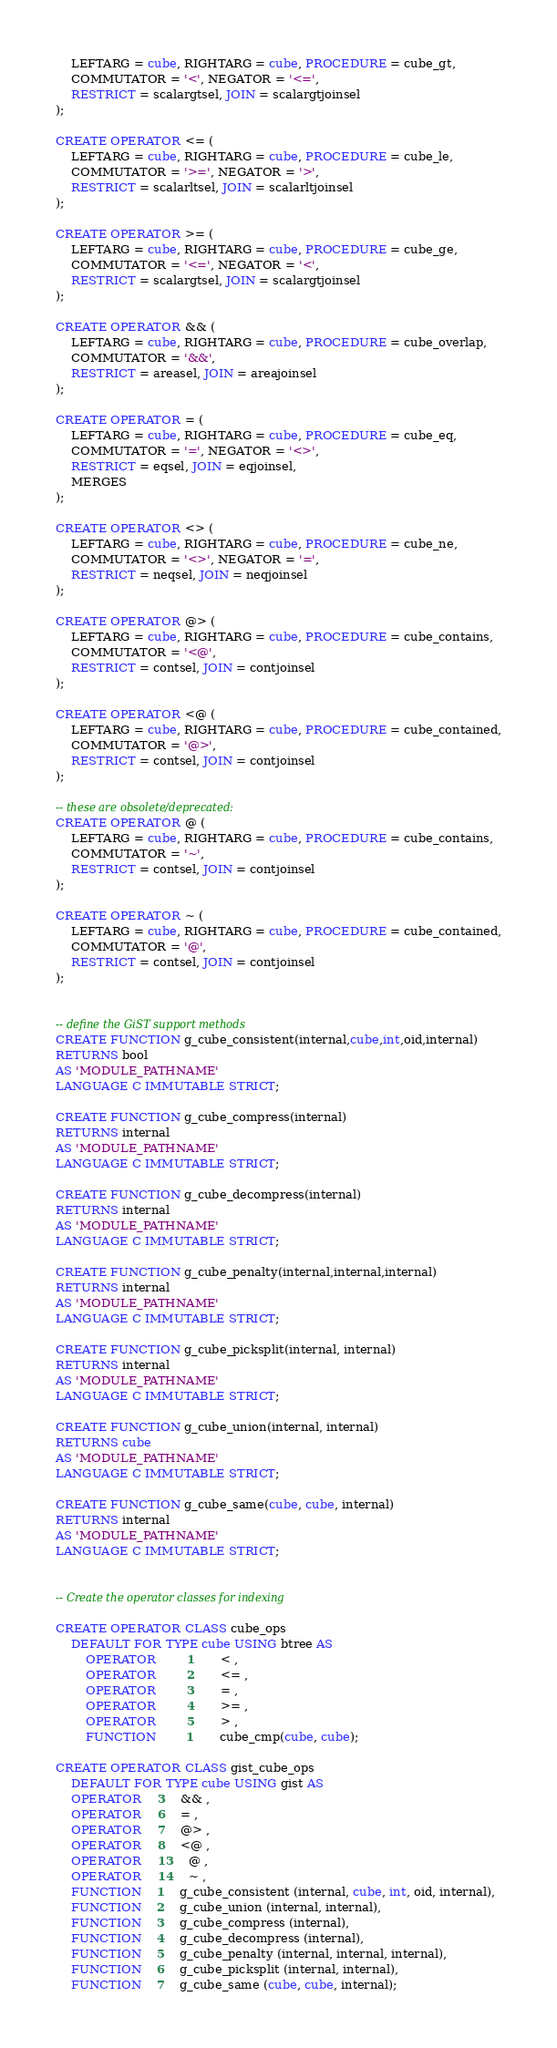<code> <loc_0><loc_0><loc_500><loc_500><_SQL_>	LEFTARG = cube, RIGHTARG = cube, PROCEDURE = cube_gt,
	COMMUTATOR = '<', NEGATOR = '<=',
	RESTRICT = scalargtsel, JOIN = scalargtjoinsel
);

CREATE OPERATOR <= (
	LEFTARG = cube, RIGHTARG = cube, PROCEDURE = cube_le,
	COMMUTATOR = '>=', NEGATOR = '>',
	RESTRICT = scalarltsel, JOIN = scalarltjoinsel
);

CREATE OPERATOR >= (
	LEFTARG = cube, RIGHTARG = cube, PROCEDURE = cube_ge,
	COMMUTATOR = '<=', NEGATOR = '<',
	RESTRICT = scalargtsel, JOIN = scalargtjoinsel
);

CREATE OPERATOR && (
	LEFTARG = cube, RIGHTARG = cube, PROCEDURE = cube_overlap,
	COMMUTATOR = '&&',
	RESTRICT = areasel, JOIN = areajoinsel
);

CREATE OPERATOR = (
	LEFTARG = cube, RIGHTARG = cube, PROCEDURE = cube_eq,
	COMMUTATOR = '=', NEGATOR = '<>',
	RESTRICT = eqsel, JOIN = eqjoinsel,
	MERGES
);

CREATE OPERATOR <> (
	LEFTARG = cube, RIGHTARG = cube, PROCEDURE = cube_ne,
	COMMUTATOR = '<>', NEGATOR = '=',
	RESTRICT = neqsel, JOIN = neqjoinsel
);

CREATE OPERATOR @> (
	LEFTARG = cube, RIGHTARG = cube, PROCEDURE = cube_contains,
	COMMUTATOR = '<@',
	RESTRICT = contsel, JOIN = contjoinsel
);

CREATE OPERATOR <@ (
	LEFTARG = cube, RIGHTARG = cube, PROCEDURE = cube_contained,
	COMMUTATOR = '@>',
	RESTRICT = contsel, JOIN = contjoinsel
);

-- these are obsolete/deprecated:
CREATE OPERATOR @ (
	LEFTARG = cube, RIGHTARG = cube, PROCEDURE = cube_contains,
	COMMUTATOR = '~',
	RESTRICT = contsel, JOIN = contjoinsel
);

CREATE OPERATOR ~ (
	LEFTARG = cube, RIGHTARG = cube, PROCEDURE = cube_contained,
	COMMUTATOR = '@',
	RESTRICT = contsel, JOIN = contjoinsel
);


-- define the GiST support methods
CREATE FUNCTION g_cube_consistent(internal,cube,int,oid,internal)
RETURNS bool
AS 'MODULE_PATHNAME'
LANGUAGE C IMMUTABLE STRICT;

CREATE FUNCTION g_cube_compress(internal)
RETURNS internal
AS 'MODULE_PATHNAME'
LANGUAGE C IMMUTABLE STRICT;

CREATE FUNCTION g_cube_decompress(internal)
RETURNS internal
AS 'MODULE_PATHNAME'
LANGUAGE C IMMUTABLE STRICT;

CREATE FUNCTION g_cube_penalty(internal,internal,internal)
RETURNS internal
AS 'MODULE_PATHNAME'
LANGUAGE C IMMUTABLE STRICT;

CREATE FUNCTION g_cube_picksplit(internal, internal)
RETURNS internal
AS 'MODULE_PATHNAME'
LANGUAGE C IMMUTABLE STRICT;

CREATE FUNCTION g_cube_union(internal, internal)
RETURNS cube
AS 'MODULE_PATHNAME'
LANGUAGE C IMMUTABLE STRICT;

CREATE FUNCTION g_cube_same(cube, cube, internal)
RETURNS internal
AS 'MODULE_PATHNAME'
LANGUAGE C IMMUTABLE STRICT;


-- Create the operator classes for indexing

CREATE OPERATOR CLASS cube_ops
    DEFAULT FOR TYPE cube USING btree AS
        OPERATOR        1       < ,
        OPERATOR        2       <= ,
        OPERATOR        3       = ,
        OPERATOR        4       >= ,
        OPERATOR        5       > ,
        FUNCTION        1       cube_cmp(cube, cube);

CREATE OPERATOR CLASS gist_cube_ops
    DEFAULT FOR TYPE cube USING gist AS
	OPERATOR	3	&& ,
	OPERATOR	6	= ,
	OPERATOR	7	@> ,
	OPERATOR	8	<@ ,
	OPERATOR	13	@ ,
	OPERATOR	14	~ ,
	FUNCTION	1	g_cube_consistent (internal, cube, int, oid, internal),
	FUNCTION	2	g_cube_union (internal, internal),
	FUNCTION	3	g_cube_compress (internal),
	FUNCTION	4	g_cube_decompress (internal),
	FUNCTION	5	g_cube_penalty (internal, internal, internal),
	FUNCTION	6	g_cube_picksplit (internal, internal),
	FUNCTION	7	g_cube_same (cube, cube, internal);
</code> 